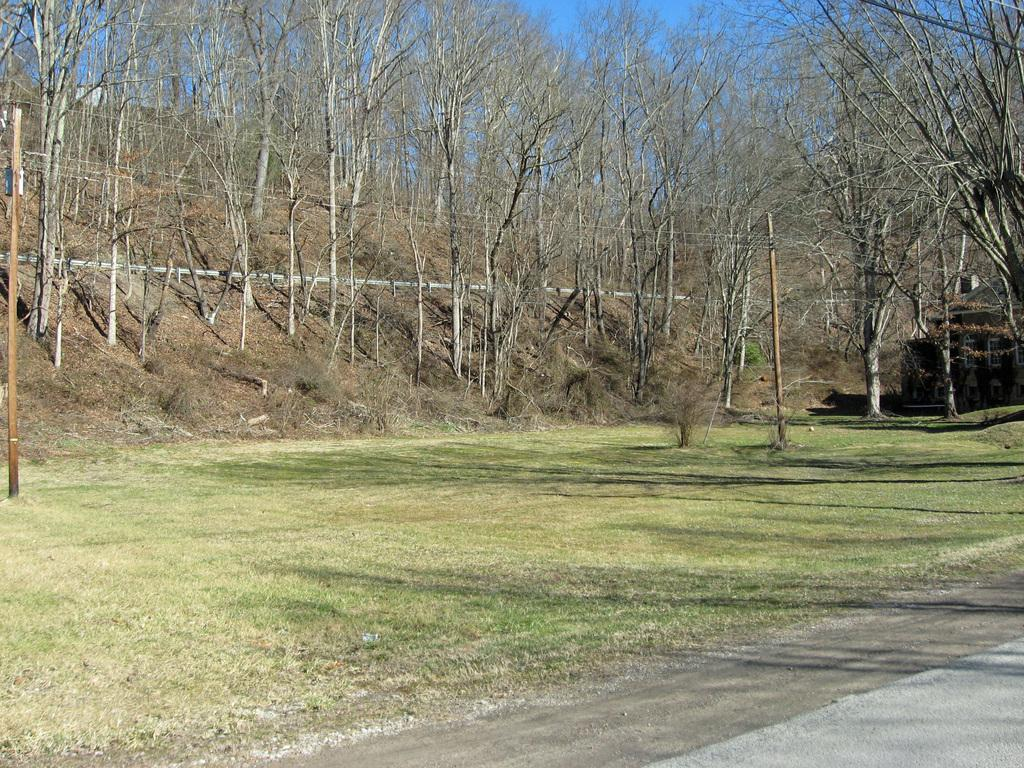What type of surface is visible in the image? There is a grass surface in the image. What can be seen around the grass in the image? There are many dry trees around the grass in the image. What type of steel structure can be seen in the image? There is no steel structure present in the image; it features a grass surface and dry trees. Can you tell me how many turkeys are visible in the image? There are no turkeys present in the image. 